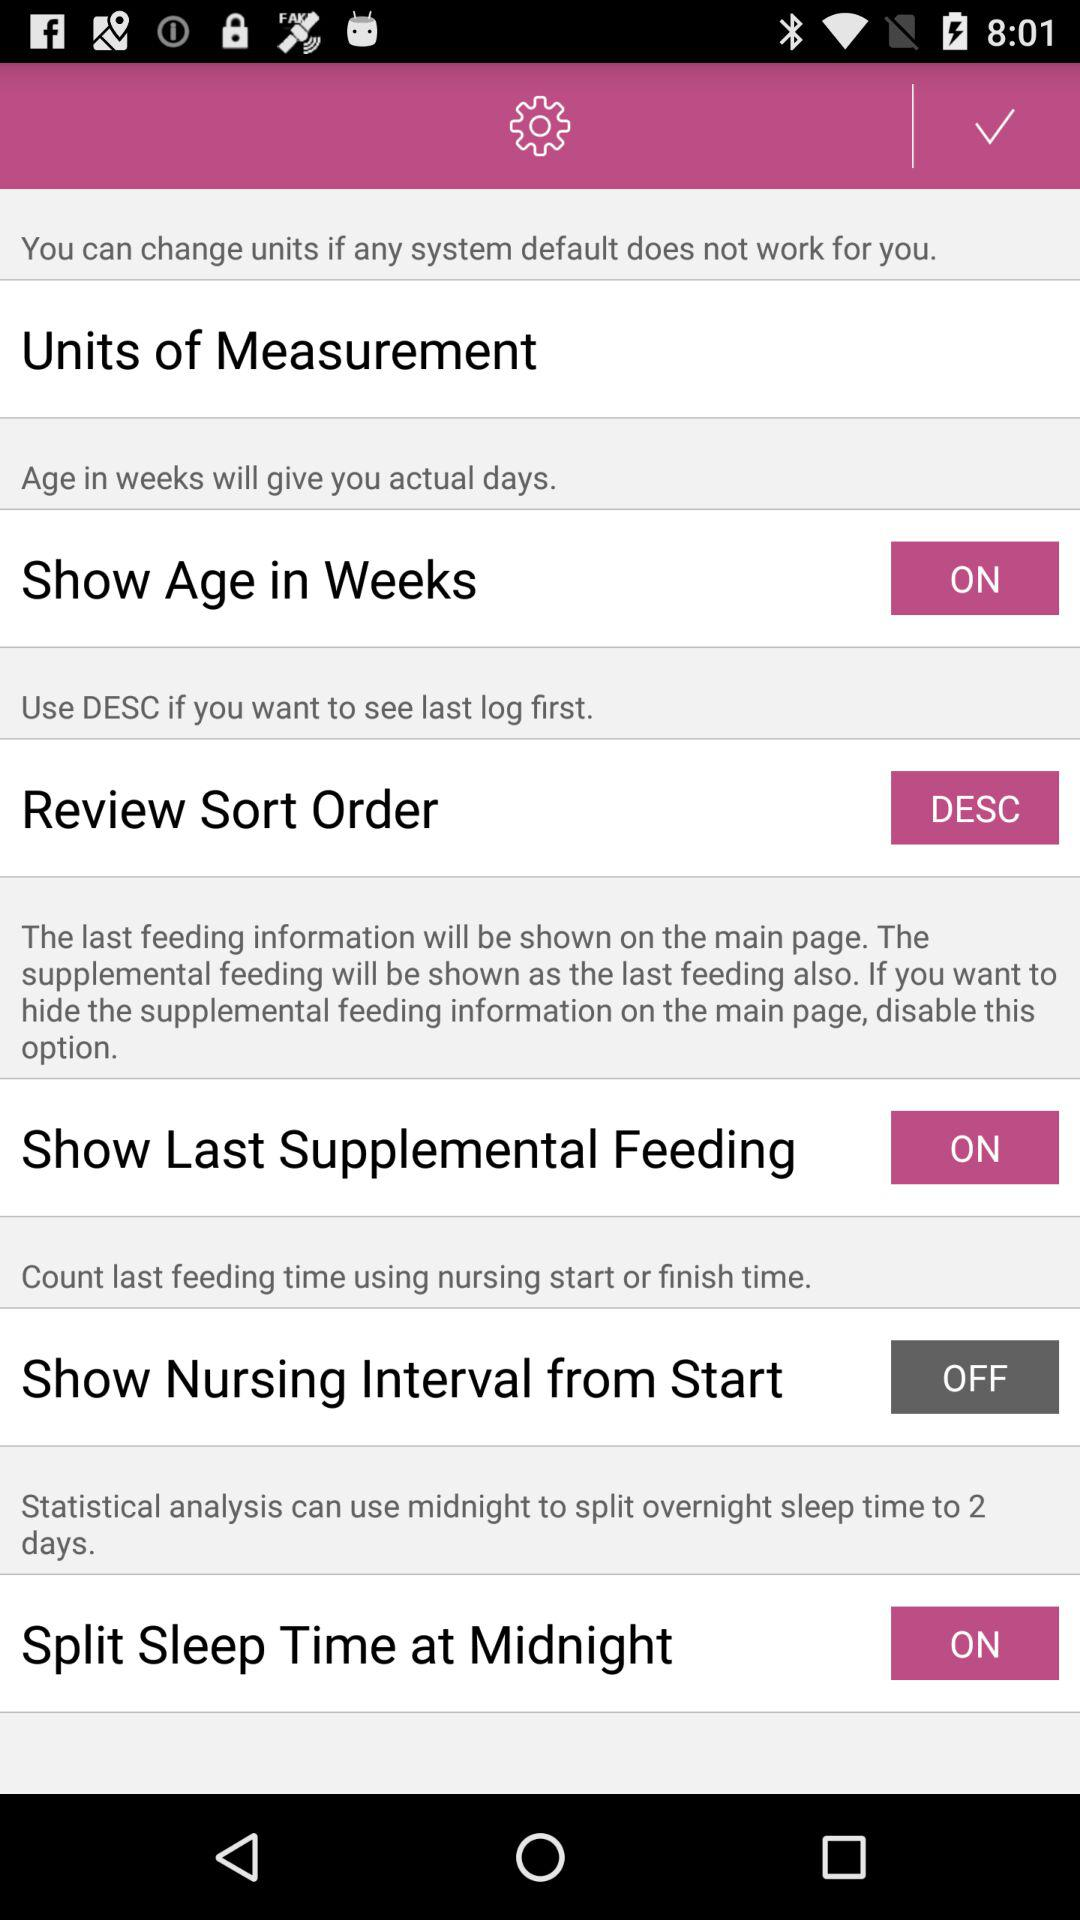What is the status of "Show Last Supplemental Feeding"? The status is "on". 